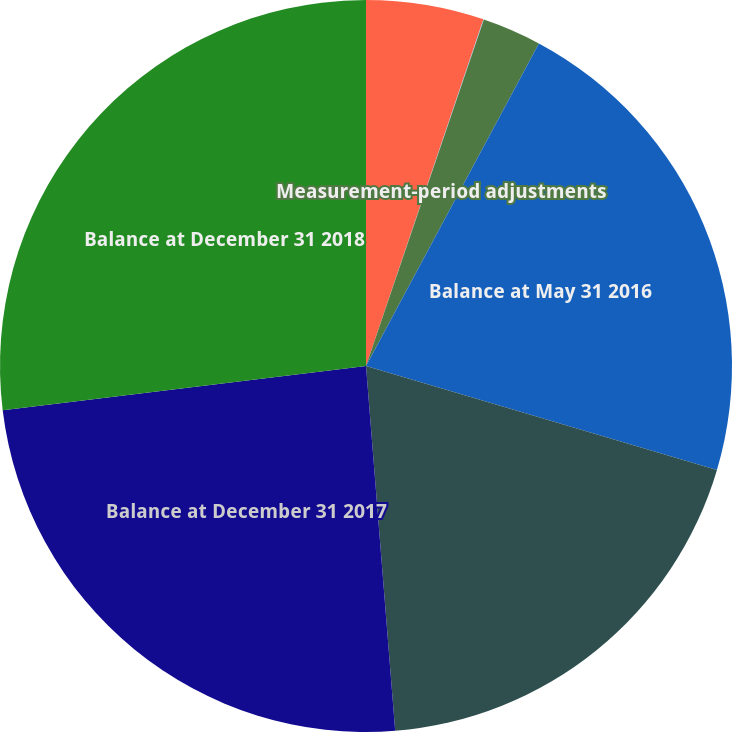Convert chart. <chart><loc_0><loc_0><loc_500><loc_500><pie_chart><fcel>Balance at May 31 2015<fcel>Effect of foreign currency<fcel>Measurement-period adjustments<fcel>Balance at May 31 2016<fcel>Balance at December 31 2016<fcel>Balance at December 31 2017<fcel>Balance at December 31 2018<nl><fcel>5.2%<fcel>0.02%<fcel>2.61%<fcel>21.75%<fcel>19.15%<fcel>24.34%<fcel>26.93%<nl></chart> 